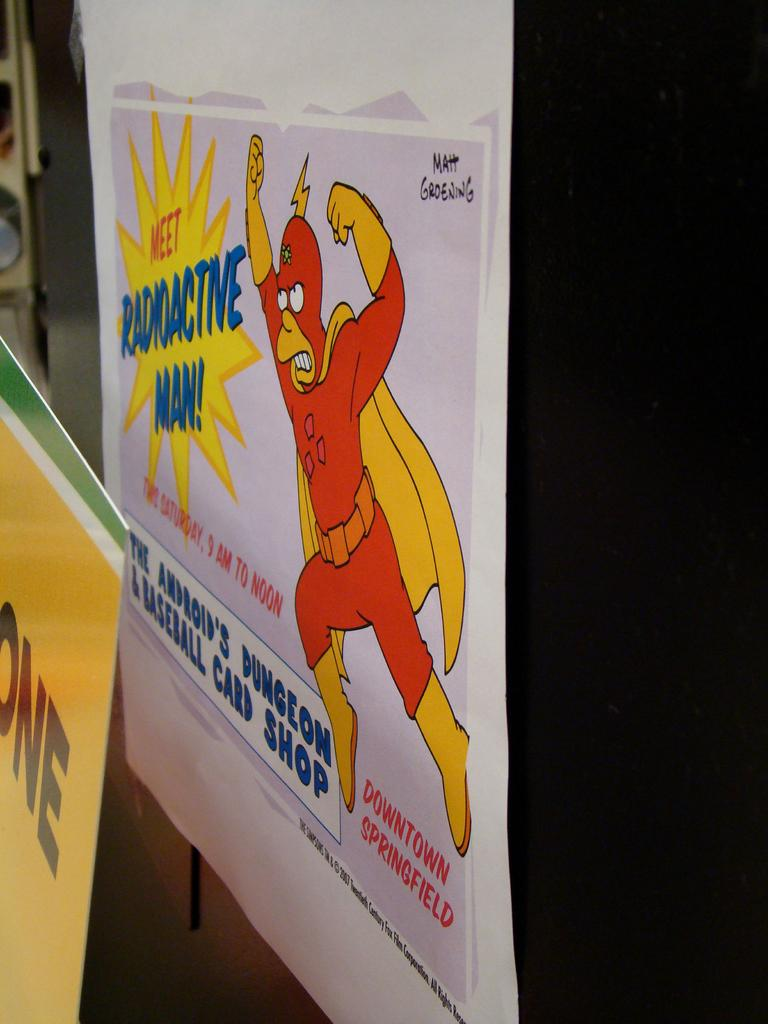<image>
Give a short and clear explanation of the subsequent image. A poster on a wall that reads "Meet Radioactive man" with a yellow background. 